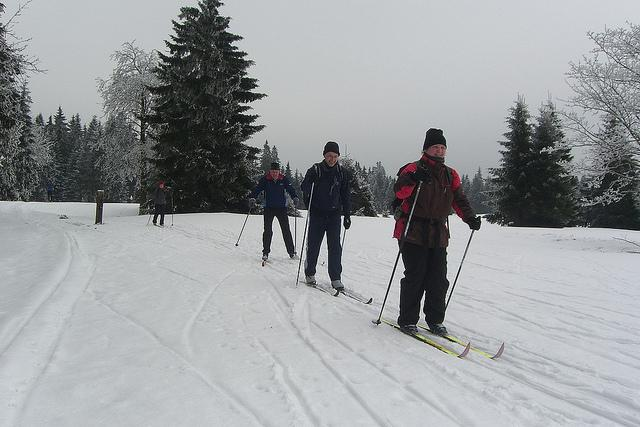What is needed for this activity? Please explain your reasoning. snow. Snow is needed for skiing. 